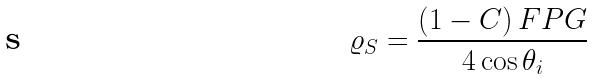<formula> <loc_0><loc_0><loc_500><loc_500>\varrho _ { S } = \frac { \left ( 1 - C \right ) F P G } { 4 \cos { \theta _ { i } } }</formula> 